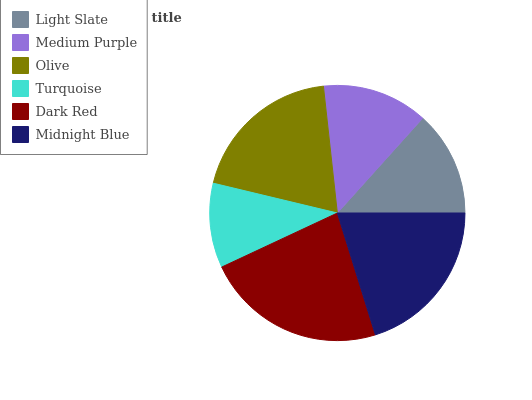Is Turquoise the minimum?
Answer yes or no. Yes. Is Dark Red the maximum?
Answer yes or no. Yes. Is Medium Purple the minimum?
Answer yes or no. No. Is Medium Purple the maximum?
Answer yes or no. No. Is Medium Purple greater than Light Slate?
Answer yes or no. Yes. Is Light Slate less than Medium Purple?
Answer yes or no. Yes. Is Light Slate greater than Medium Purple?
Answer yes or no. No. Is Medium Purple less than Light Slate?
Answer yes or no. No. Is Olive the high median?
Answer yes or no. Yes. Is Medium Purple the low median?
Answer yes or no. Yes. Is Light Slate the high median?
Answer yes or no. No. Is Dark Red the low median?
Answer yes or no. No. 